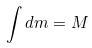<formula> <loc_0><loc_0><loc_500><loc_500>\int d m = M</formula> 